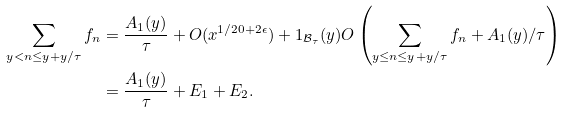<formula> <loc_0><loc_0><loc_500><loc_500>\sum _ { y < n \leq y + y / \tau } f _ { n } & = \frac { A _ { 1 } ( y ) } { \tau } + O ( x ^ { 1 / 2 0 + 2 \epsilon } ) + 1 _ { \mathcal { B } _ { \tau } } ( y ) O \left ( \sum _ { y \leq n \leq y + y / \tau } f _ { n } + A _ { 1 } ( y ) / \tau \right ) \\ & = \frac { A _ { 1 } ( y ) } { \tau } + E _ { 1 } + E _ { 2 } .</formula> 